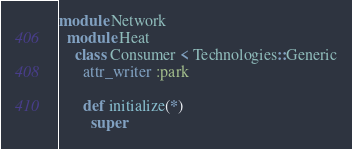<code> <loc_0><loc_0><loc_500><loc_500><_Ruby_>module Network
  module Heat
    class Consumer < Technologies::Generic
      attr_writer :park

      def initialize(*)
        super</code> 